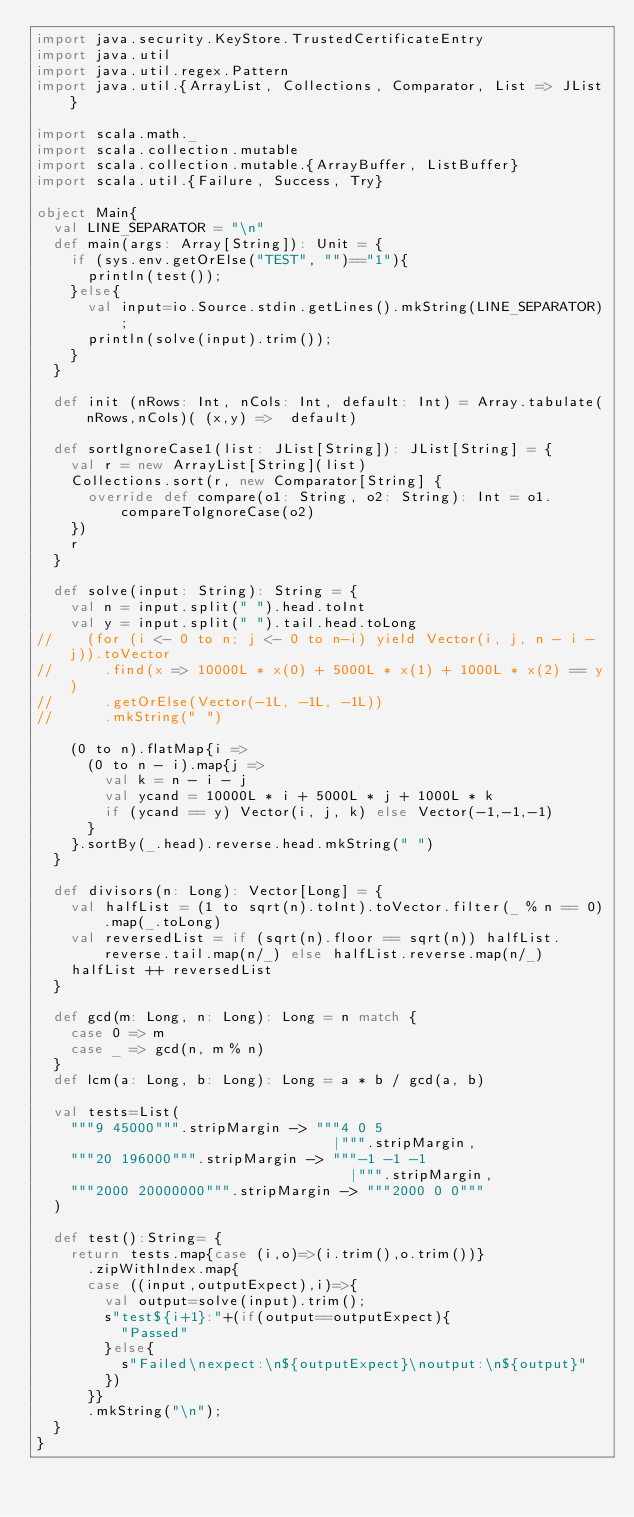<code> <loc_0><loc_0><loc_500><loc_500><_Scala_>import java.security.KeyStore.TrustedCertificateEntry
import java.util
import java.util.regex.Pattern
import java.util.{ArrayList, Collections, Comparator, List => JList}

import scala.math._
import scala.collection.mutable
import scala.collection.mutable.{ArrayBuffer, ListBuffer}
import scala.util.{Failure, Success, Try}

object Main{
  val LINE_SEPARATOR = "\n"
  def main(args: Array[String]): Unit = {
    if (sys.env.getOrElse("TEST", "")=="1"){
      println(test());
    }else{
      val input=io.Source.stdin.getLines().mkString(LINE_SEPARATOR);
      println(solve(input).trim());
    }
  }

  def init (nRows: Int, nCols: Int, default: Int) = Array.tabulate(nRows,nCols)( (x,y) =>  default)

  def sortIgnoreCase1(list: JList[String]): JList[String] = {
    val r = new ArrayList[String](list)
    Collections.sort(r, new Comparator[String] {
      override def compare(o1: String, o2: String): Int = o1.compareToIgnoreCase(o2)
    })
    r
  }

  def solve(input: String): String = {
    val n = input.split(" ").head.toInt
    val y = input.split(" ").tail.head.toLong
//    (for (i <- 0 to n; j <- 0 to n-i) yield Vector(i, j, n - i - j)).toVector
//      .find(x => 10000L * x(0) + 5000L * x(1) + 1000L * x(2) == y)
//      .getOrElse(Vector(-1L, -1L, -1L))
//      .mkString(" ")

    (0 to n).flatMap{i =>
      (0 to n - i).map{j =>
        val k = n - i - j
        val ycand = 10000L * i + 5000L * j + 1000L * k
        if (ycand == y) Vector(i, j, k) else Vector(-1,-1,-1)
      }
    }.sortBy(_.head).reverse.head.mkString(" ")
  }

  def divisors(n: Long): Vector[Long] = {
    val halfList = (1 to sqrt(n).toInt).toVector.filter(_ % n == 0).map(_.toLong)
    val reversedList = if (sqrt(n).floor == sqrt(n)) halfList.reverse.tail.map(n/_) else halfList.reverse.map(n/_)
    halfList ++ reversedList
  }

  def gcd(m: Long, n: Long): Long = n match {
    case 0 => m
    case _ => gcd(n, m % n)
  }
  def lcm(a: Long, b: Long): Long = a * b / gcd(a, b)

  val tests=List(
    """9 45000""".stripMargin -> """4 0 5
                                   |""".stripMargin,
    """20 196000""".stripMargin -> """-1 -1 -1
                                     |""".stripMargin,
    """2000 20000000""".stripMargin -> """2000 0 0"""
  )

  def test():String= {
    return tests.map{case (i,o)=>(i.trim(),o.trim())}
      .zipWithIndex.map{
      case ((input,outputExpect),i)=>{
        val output=solve(input).trim();
        s"test${i+1}:"+(if(output==outputExpect){
          "Passed"
        }else{
          s"Failed\nexpect:\n${outputExpect}\noutput:\n${output}"
        })
      }}
      .mkString("\n");
  }
}</code> 